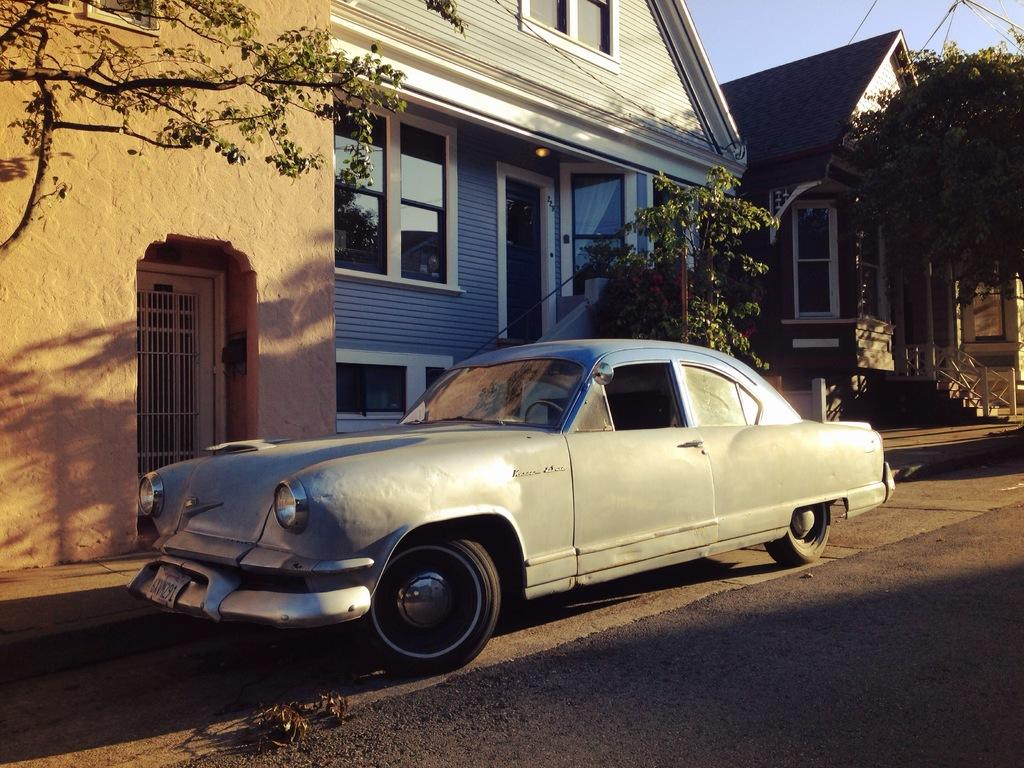How many houses are visible in the image? There are two houses in the image. What is located on the left side of the image? There is a wall on the left side of the image. What is parked in front of the wall on the road? A car is parked in front of the wall on the road. What type of vegetation is in front of the houses? There are trees in front of the houses. How many cream-filled snakes are visible on the tray in the image? There is no tray or cream-filled snakes present in the image. 